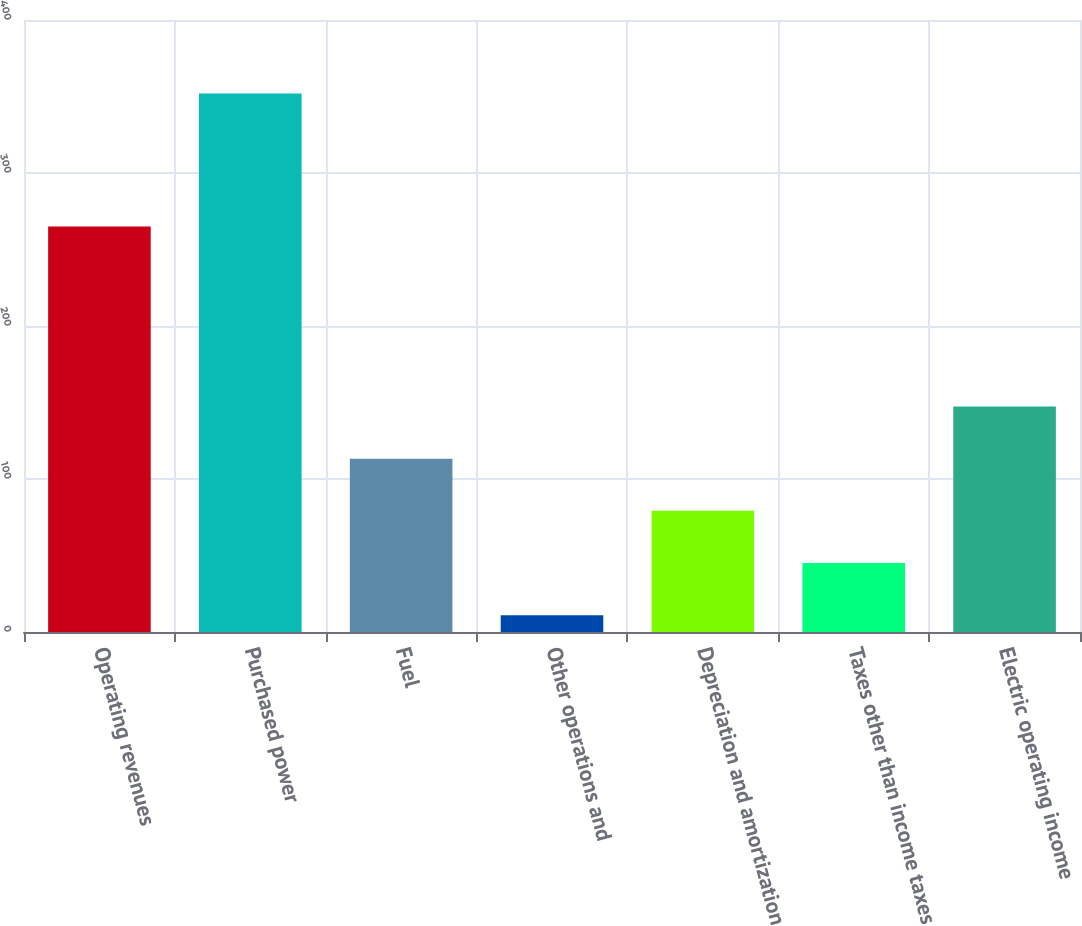Convert chart. <chart><loc_0><loc_0><loc_500><loc_500><bar_chart><fcel>Operating revenues<fcel>Purchased power<fcel>Fuel<fcel>Other operations and<fcel>Depreciation and amortization<fcel>Taxes other than income taxes<fcel>Electric operating income<nl><fcel>265<fcel>352<fcel>113.3<fcel>11<fcel>79.2<fcel>45.1<fcel>147.4<nl></chart> 